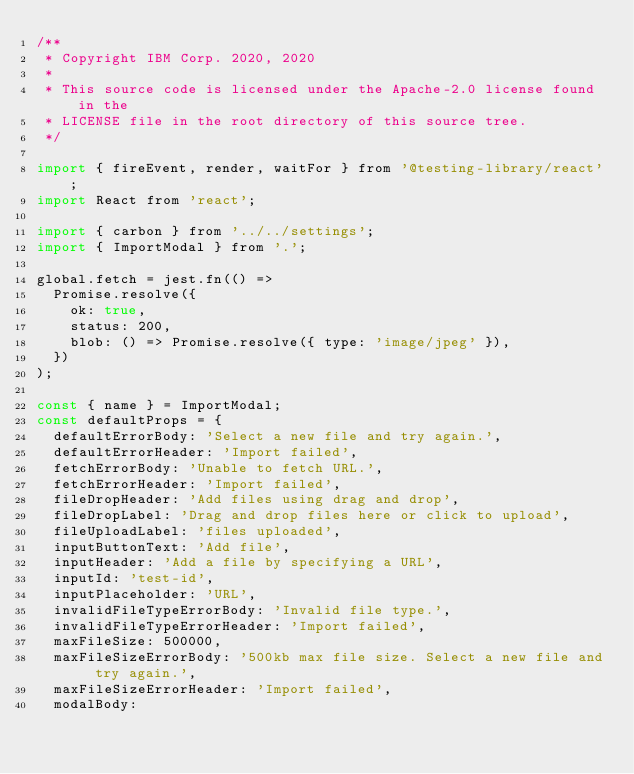Convert code to text. <code><loc_0><loc_0><loc_500><loc_500><_JavaScript_>/**
 * Copyright IBM Corp. 2020, 2020
 *
 * This source code is licensed under the Apache-2.0 license found in the
 * LICENSE file in the root directory of this source tree.
 */

import { fireEvent, render, waitFor } from '@testing-library/react';
import React from 'react';

import { carbon } from '../../settings';
import { ImportModal } from '.';

global.fetch = jest.fn(() =>
  Promise.resolve({
    ok: true,
    status: 200,
    blob: () => Promise.resolve({ type: 'image/jpeg' }),
  })
);

const { name } = ImportModal;
const defaultProps = {
  defaultErrorBody: 'Select a new file and try again.',
  defaultErrorHeader: 'Import failed',
  fetchErrorBody: 'Unable to fetch URL.',
  fetchErrorHeader: 'Import failed',
  fileDropHeader: 'Add files using drag and drop',
  fileDropLabel: 'Drag and drop files here or click to upload',
  fileUploadLabel: 'files uploaded',
  inputButtonText: 'Add file',
  inputHeader: 'Add a file by specifying a URL',
  inputId: 'test-id',
  inputPlaceholder: 'URL',
  invalidFileTypeErrorBody: 'Invalid file type.',
  invalidFileTypeErrorHeader: 'Import failed',
  maxFileSize: 500000,
  maxFileSizeErrorBody: '500kb max file size. Select a new file and try again.',
  maxFileSizeErrorHeader: 'Import failed',
  modalBody:</code> 